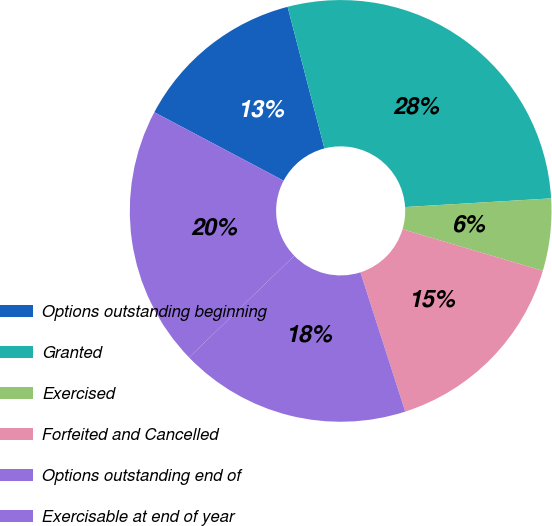Convert chart. <chart><loc_0><loc_0><loc_500><loc_500><pie_chart><fcel>Options outstanding beginning<fcel>Granted<fcel>Exercised<fcel>Forfeited and Cancelled<fcel>Options outstanding end of<fcel>Exercisable at end of year<nl><fcel>13.2%<fcel>28.1%<fcel>5.53%<fcel>15.46%<fcel>17.72%<fcel>19.98%<nl></chart> 